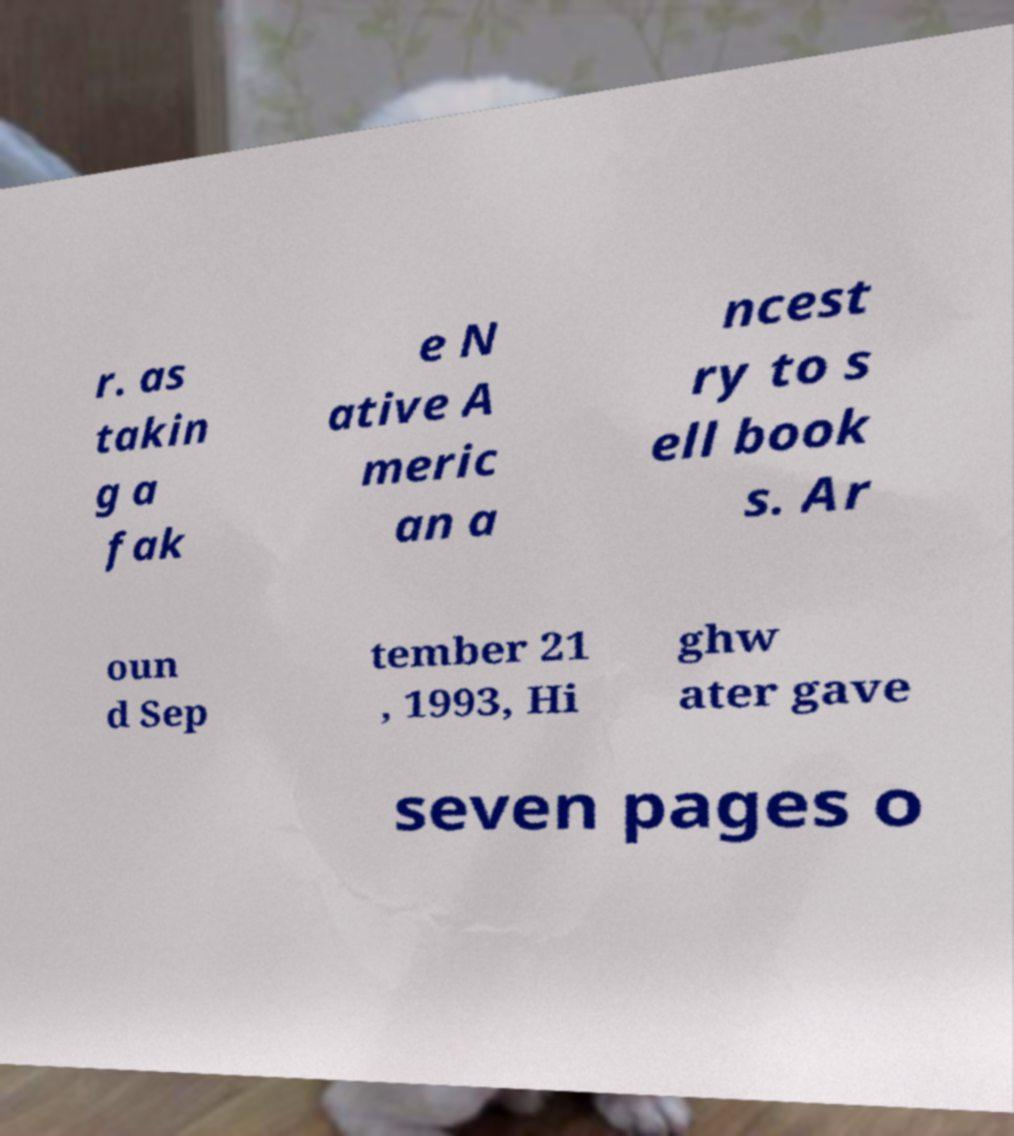Can you accurately transcribe the text from the provided image for me? r. as takin g a fak e N ative A meric an a ncest ry to s ell book s. Ar oun d Sep tember 21 , 1993, Hi ghw ater gave seven pages o 